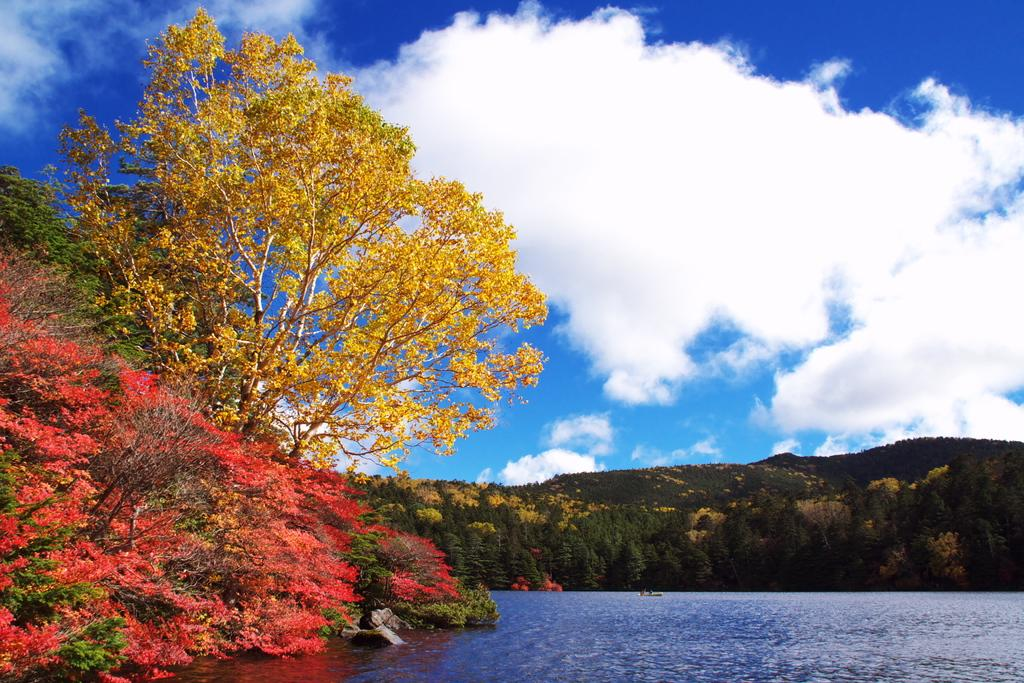What type of vegetation can be seen in the image? There are plants and trees in the image. What is located in the center of the image? There is water in the center of the image. What is the condition of the sky in the image? The sky is cloudy in the image. Can you hear the laughter of the person holding the rifle in the image? There is no person holding a rifle or any laughter present in the image, as it features plants, trees, water, and a cloudy sky. 